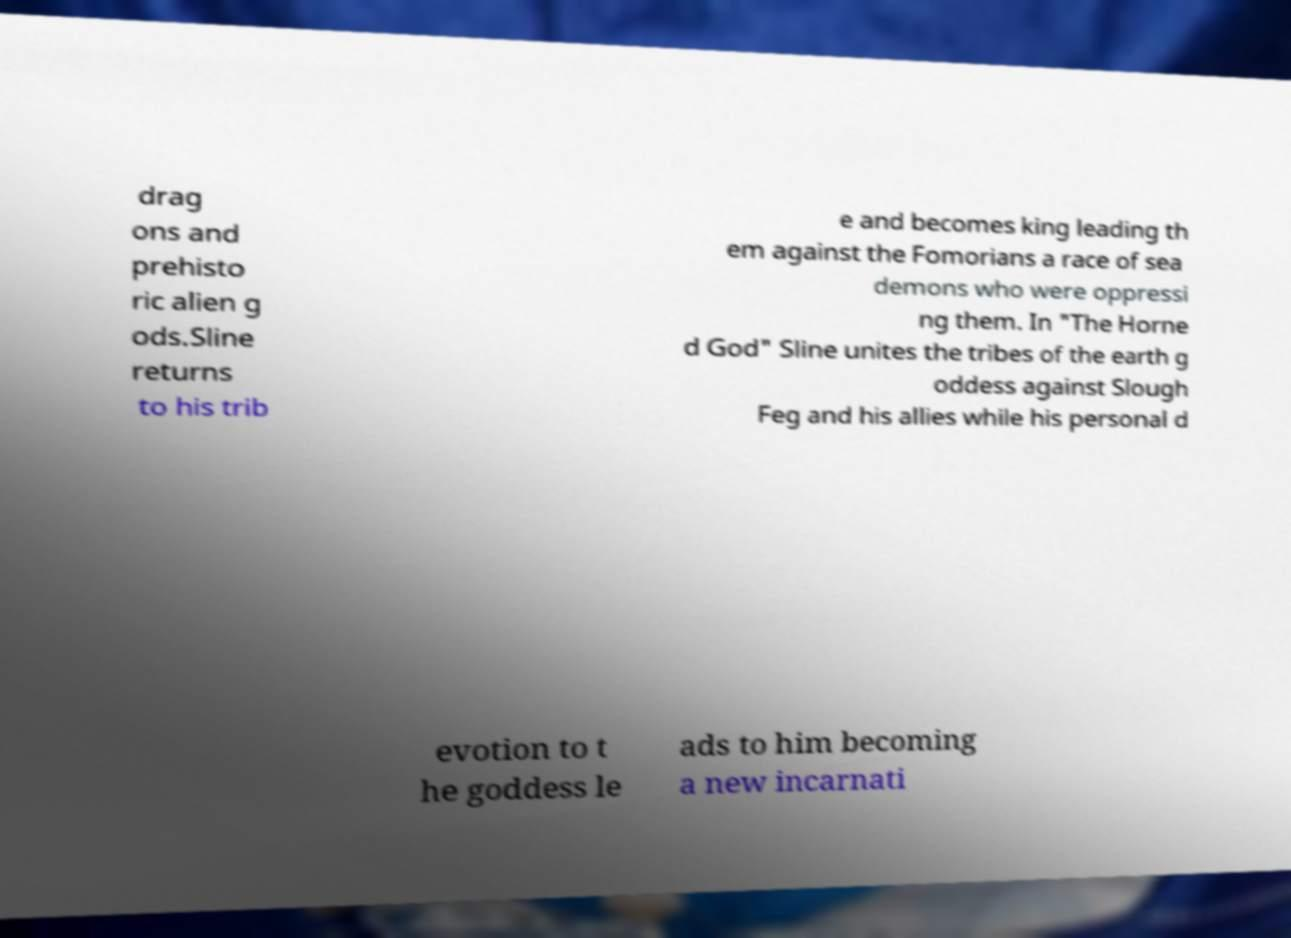Please identify and transcribe the text found in this image. drag ons and prehisto ric alien g ods.Sline returns to his trib e and becomes king leading th em against the Fomorians a race of sea demons who were oppressi ng them. In "The Horne d God" Sline unites the tribes of the earth g oddess against Slough Feg and his allies while his personal d evotion to t he goddess le ads to him becoming a new incarnati 